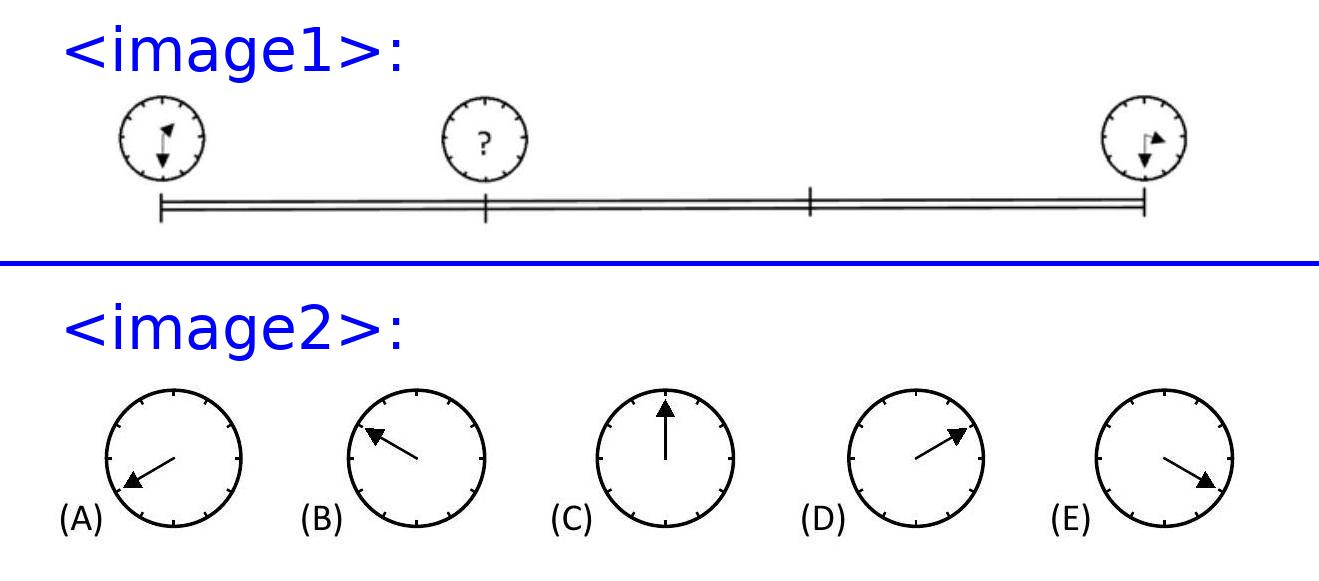Patricia drives one afternoon at a constant speed to her friend. She looks at her watch as she leaves and when she arrives.
In which position will the minute hand be when she has completed one third of her journey?
<image2> Choices: ['A', 'B', 'C', 'D', 'E'] Answer is D. 